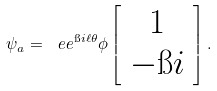Convert formula to latex. <formula><loc_0><loc_0><loc_500><loc_500>\psi _ { a } = \ e e ^ { \i i \ell \theta } \phi \left [ \begin{array} { c } 1 \\ - \i i \end{array} \right ] .</formula> 